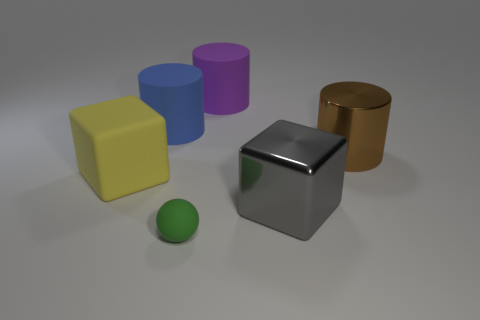Which objects in the image could fit into a small box? The small green sphere could easily fit into a small box; however, the other objects are too large for a small box. 